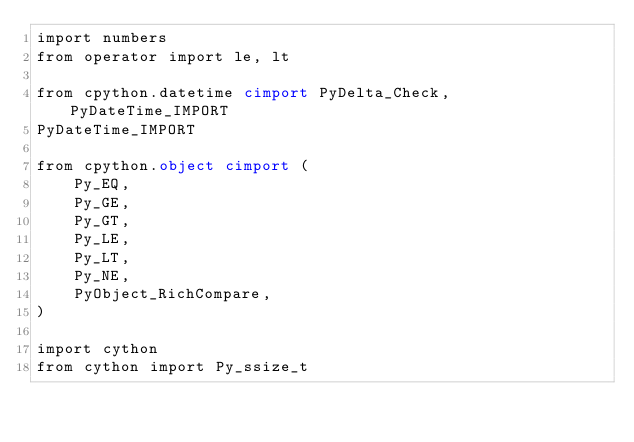Convert code to text. <code><loc_0><loc_0><loc_500><loc_500><_Cython_>import numbers
from operator import le, lt

from cpython.datetime cimport PyDelta_Check, PyDateTime_IMPORT
PyDateTime_IMPORT

from cpython.object cimport (
    Py_EQ,
    Py_GE,
    Py_GT,
    Py_LE,
    Py_LT,
    Py_NE,
    PyObject_RichCompare,
)

import cython
from cython import Py_ssize_t
</code> 